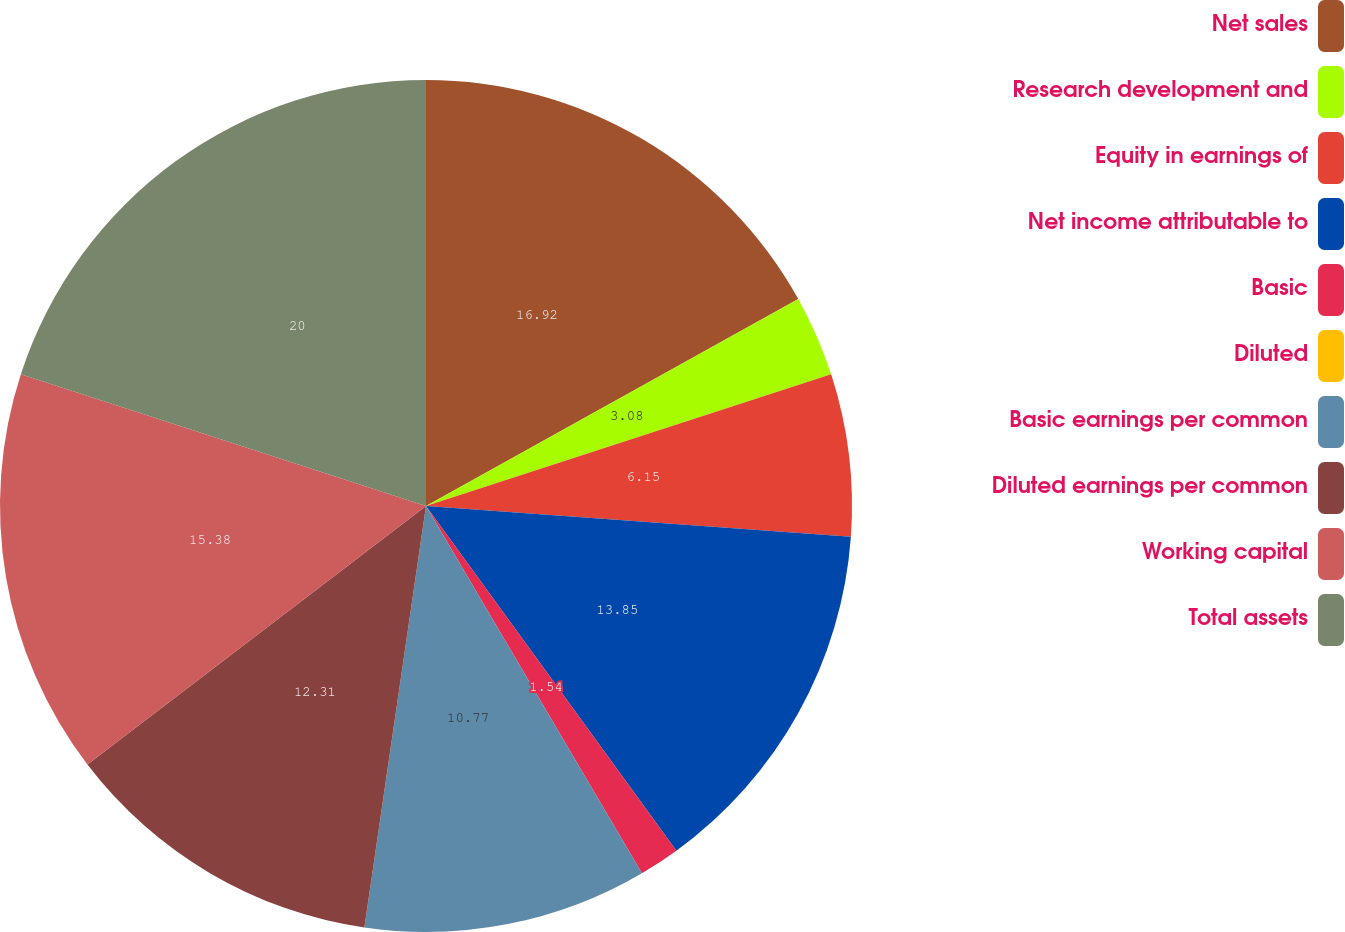Convert chart. <chart><loc_0><loc_0><loc_500><loc_500><pie_chart><fcel>Net sales<fcel>Research development and<fcel>Equity in earnings of<fcel>Net income attributable to<fcel>Basic<fcel>Diluted<fcel>Basic earnings per common<fcel>Diluted earnings per common<fcel>Working capital<fcel>Total assets<nl><fcel>16.92%<fcel>3.08%<fcel>6.15%<fcel>13.85%<fcel>1.54%<fcel>0.0%<fcel>10.77%<fcel>12.31%<fcel>15.38%<fcel>20.0%<nl></chart> 